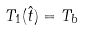<formula> <loc_0><loc_0><loc_500><loc_500>T _ { 1 } ( \hat { t } ) = T _ { b }</formula> 